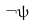<formula> <loc_0><loc_0><loc_500><loc_500>\neg \psi</formula> 